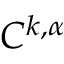<formula> <loc_0><loc_0><loc_500><loc_500>C ^ { k , \alpha }</formula> 